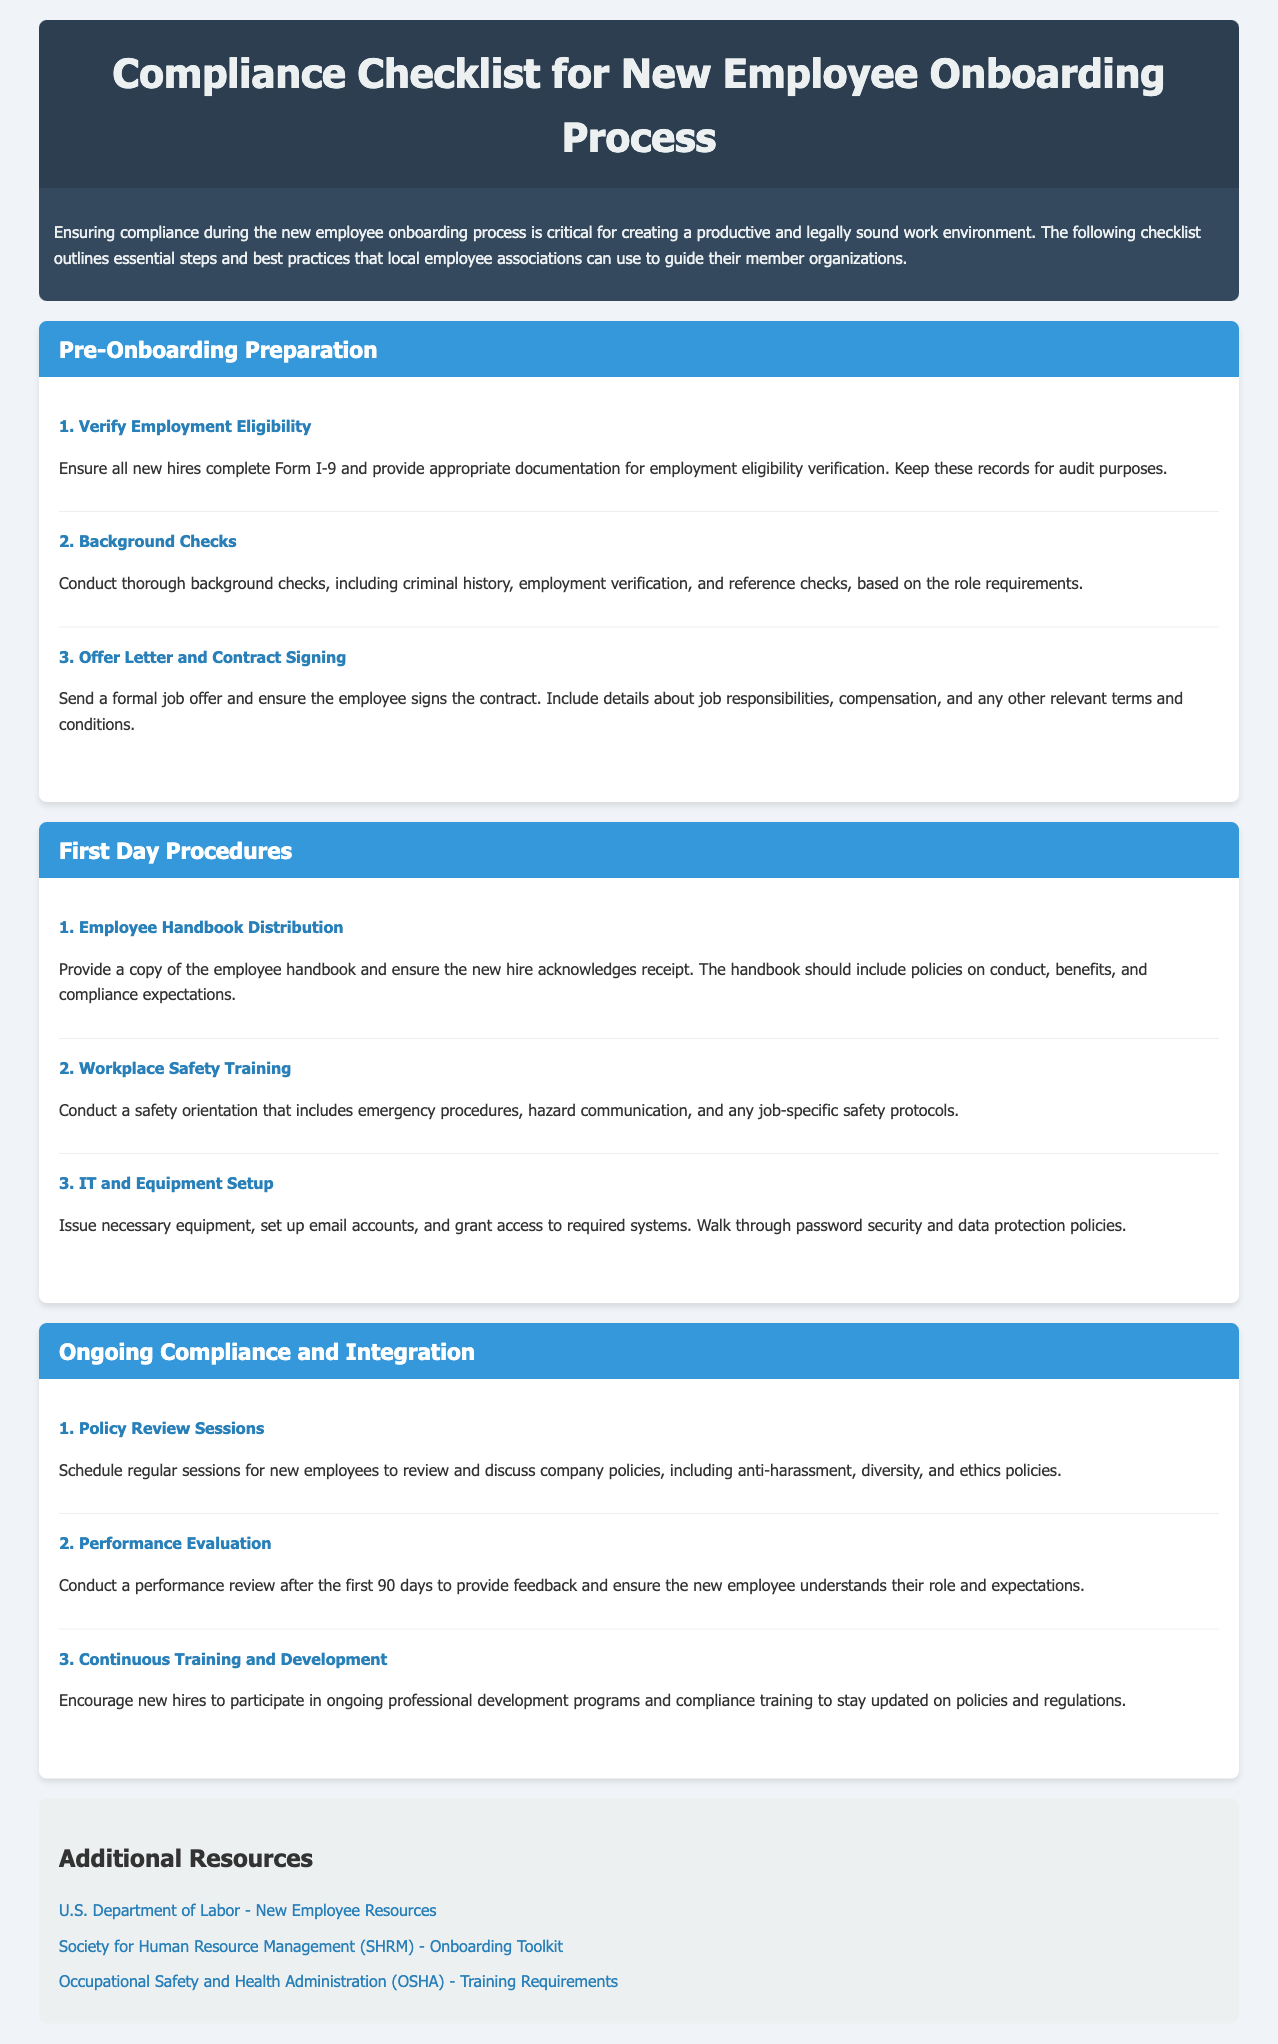What is the title of the document? The title of the document can be found in the header section.
Answer: Compliance Checklist for New Employee Onboarding Process How many steps are listed under Pre-Onboarding Preparation? The number of steps under this section can be counted in the corresponding section.
Answer: 3 What is the first step in First Day Procedures? The first step in this section is stated clearly at the beginning of the steps listed.
Answer: Employee Handbook Distribution What resource is provided by the U.S. Department of Labor? The document lists resources with specific titles and links to their content.
Answer: New Employee Resources What is the purpose of the Policy Review Sessions? The explanation of this step provides insight into its purpose related to company policies.
Answer: Review and discuss company policies What training is conducted on the first day? The section detailing first day procedures includes this specific type of training.
Answer: Workplace Safety Training How many additional resources are provided? The additional resources section lists several resources which can be counted.
Answer: 3 What is one subject included in the continuous training and development? Continuous training should cover broad topics as mentioned in the ongoing compliance section.
Answer: Compliance training What kind of checks are conducted during the Pre-Onboarding Preparation? The Pre-Onboarding Preparation section specifically mentions the type of checks to be conducted.
Answer: Background checks 